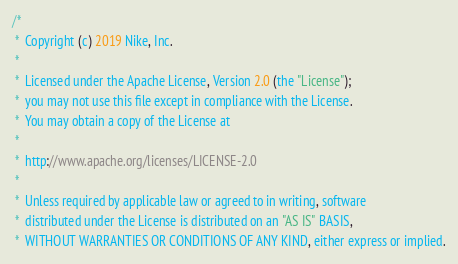<code> <loc_0><loc_0><loc_500><loc_500><_Go_>/*
 *  Copyright (c) 2019 Nike, Inc.
 *
 *  Licensed under the Apache License, Version 2.0 (the "License");
 *  you may not use this file except in compliance with the License.
 *  You may obtain a copy of the License at
 *
 *  http://www.apache.org/licenses/LICENSE-2.0
 *
 *  Unless required by applicable law or agreed to in writing, software
 *  distributed under the License is distributed on an "AS IS" BASIS,
 *  WITHOUT WARRANTIES OR CONDITIONS OF ANY KIND, either express or implied.</code> 